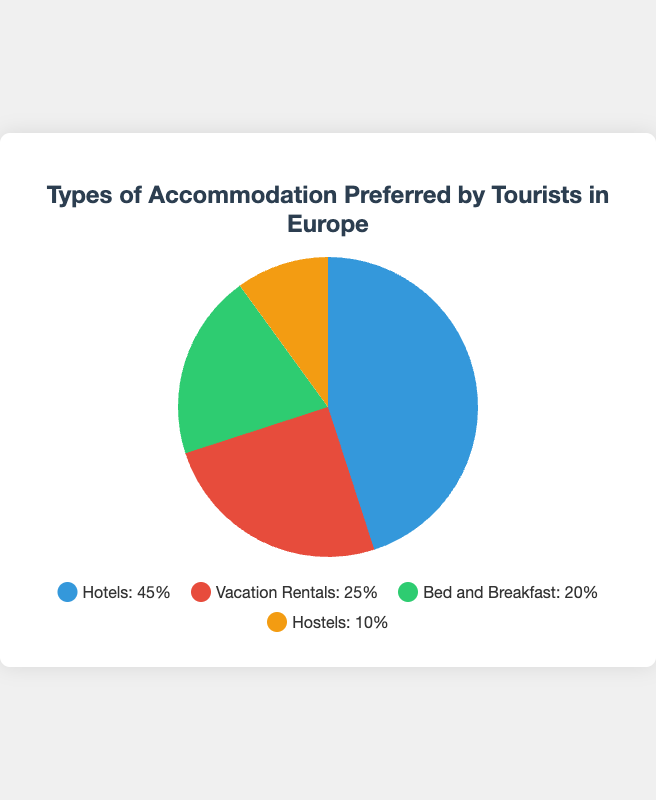What type of accommodation is preferred by the highest percentage of tourists? The pie chart shows that Hotels have the largest slice, which covers more area than the other types of accommodations. Thus, Hotels are preferred by the highest percentage of tourists.
Answer: Hotels Which type of accommodation is preferred by the least percentage of tourists? The smallest slice in the pie chart represents Hostels, indicating they are the least preferred type of accommodation among tourists.
Answer: Hostels How many times greater is the percentage of tourists who prefer Hotels compared to those who prefer Hostels? The percentage of tourists who prefer Hotels is 45%, and for Hostels, it's 10%. To find how many times greater, divide 45 by 10. 45/10 = 4.5.
Answer: 4.5 What is the combined percentage of tourists who prefer Bed and Breakfast and Hostels? The pie chart shows Bed and Breakfast with 20% and Hostels with 10%. Adding these two percentages gives us 20% + 10% = 30%.
Answer: 30% Is the percentage of tourists preferring Vacation Rentals more or less than those preferring Hotels? The pie chart shows that Vacation Rentals account for 25% of preferences, while Hotels account for 45%. Since 25% is less than 45%, Vacation Rentals have fewer preferences compared to Hotels.
Answer: Less What color represents the Bed and Breakfast slice in the pie chart? The legend indicates that each accommodation type's percentage is denoted by a distinct color. The slice for Bed and Breakfast is shown in green in the chart.
Answer: Green How much larger is the slice for Hotels compared to Bed and Breakfast? The percentage of tourists preferring Hotels is 45%, while for Bed and Breakfast, it is 20%. To find how much larger, subtract 20 from 45. 45 - 20 = 25%.
Answer: 25% What is the percentage difference between the top two preferred accommodations? The top two preferred accommodations are Hotels (45%) and Vacation Rentals (25%). The percentage difference between them is calculated as 45% - 25% = 20%.
Answer: 20% Which two types of accommodations together make up half of the total preferences? The two types of accommodations with percentages adding up to 50% need to be identified. Vacation Rentals (25%) and Bed and Breakfast (20%) together are 45%, which is not half. Hotels (45%) and Hostels (10%) make exactly 55%, not half. But Hotels (45%) and another type totaling 5% don’t exist. Thus, no exact half among combinations, but the two closing are Hotels and Vacation Rentals (45% + 25% = 70%).
Answer: None If the slice for Hostels were to double, what percentage of the pie chart would it occupy? Currently, Hostels occupy 10%. If it were to double, it would be 10% * 2 = 20%.
Answer: 20% 